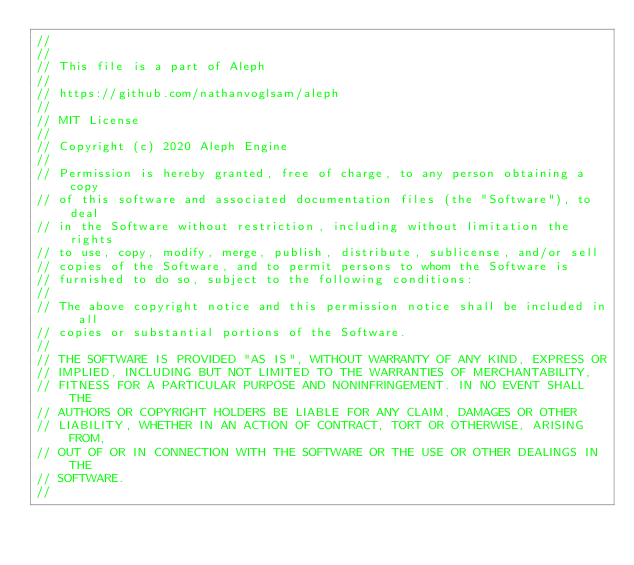<code> <loc_0><loc_0><loc_500><loc_500><_Rust_>//
//
// This file is a part of Aleph
//
// https://github.com/nathanvoglsam/aleph
//
// MIT License
//
// Copyright (c) 2020 Aleph Engine
//
// Permission is hereby granted, free of charge, to any person obtaining a copy
// of this software and associated documentation files (the "Software"), to deal
// in the Software without restriction, including without limitation the rights
// to use, copy, modify, merge, publish, distribute, sublicense, and/or sell
// copies of the Software, and to permit persons to whom the Software is
// furnished to do so, subject to the following conditions:
//
// The above copyright notice and this permission notice shall be included in all
// copies or substantial portions of the Software.
//
// THE SOFTWARE IS PROVIDED "AS IS", WITHOUT WARRANTY OF ANY KIND, EXPRESS OR
// IMPLIED, INCLUDING BUT NOT LIMITED TO THE WARRANTIES OF MERCHANTABILITY,
// FITNESS FOR A PARTICULAR PURPOSE AND NONINFRINGEMENT. IN NO EVENT SHALL THE
// AUTHORS OR COPYRIGHT HOLDERS BE LIABLE FOR ANY CLAIM, DAMAGES OR OTHER
// LIABILITY, WHETHER IN AN ACTION OF CONTRACT, TORT OR OTHERWISE, ARISING FROM,
// OUT OF OR IN CONNECTION WITH THE SOFTWARE OR THE USE OR OTHER DEALINGS IN THE
// SOFTWARE.
//
</code> 